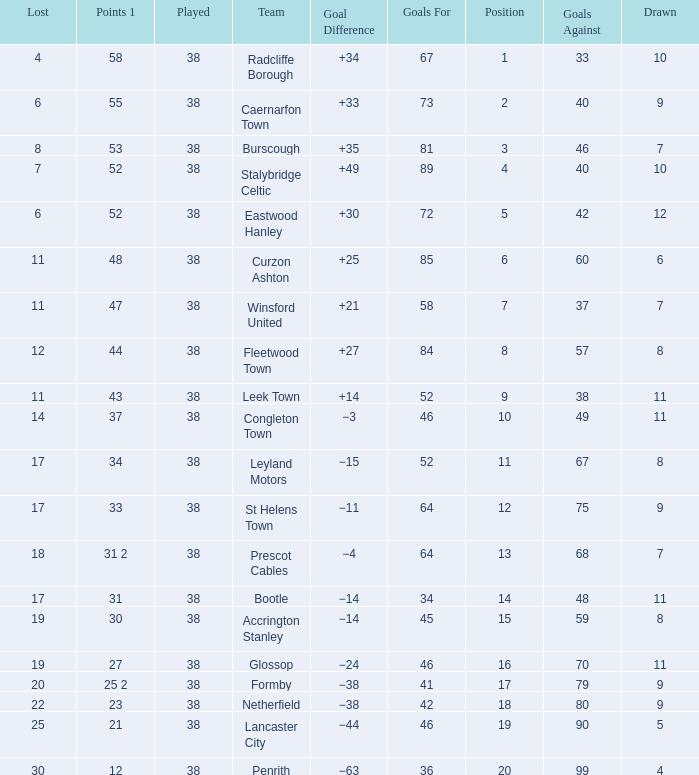Parse the full table. {'header': ['Lost', 'Points 1', 'Played', 'Team', 'Goal Difference', 'Goals For', 'Position', 'Goals Against', 'Drawn'], 'rows': [['4', '58', '38', 'Radcliffe Borough', '+34', '67', '1', '33', '10'], ['6', '55', '38', 'Caernarfon Town', '+33', '73', '2', '40', '9'], ['8', '53', '38', 'Burscough', '+35', '81', '3', '46', '7'], ['7', '52', '38', 'Stalybridge Celtic', '+49', '89', '4', '40', '10'], ['6', '52', '38', 'Eastwood Hanley', '+30', '72', '5', '42', '12'], ['11', '48', '38', 'Curzon Ashton', '+25', '85', '6', '60', '6'], ['11', '47', '38', 'Winsford United', '+21', '58', '7', '37', '7'], ['12', '44', '38', 'Fleetwood Town', '+27', '84', '8', '57', '8'], ['11', '43', '38', 'Leek Town', '+14', '52', '9', '38', '11'], ['14', '37', '38', 'Congleton Town', '−3', '46', '10', '49', '11'], ['17', '34', '38', 'Leyland Motors', '−15', '52', '11', '67', '8'], ['17', '33', '38', 'St Helens Town', '−11', '64', '12', '75', '9'], ['18', '31 2', '38', 'Prescot Cables', '−4', '64', '13', '68', '7'], ['17', '31', '38', 'Bootle', '−14', '34', '14', '48', '11'], ['19', '30', '38', 'Accrington Stanley', '−14', '45', '15', '59', '8'], ['19', '27', '38', 'Glossop', '−24', '46', '16', '70', '11'], ['20', '25 2', '38', 'Formby', '−38', '41', '17', '79', '9'], ['22', '23', '38', 'Netherfield', '−38', '42', '18', '80', '9'], ['25', '21', '38', 'Lancaster City', '−44', '46', '19', '90', '5'], ['30', '12', '38', 'Penrith', '−63', '36', '20', '99', '4']]} WHAT IS THE POSITION WITH A LOST OF 6, FOR CAERNARFON TOWN? 2.0. 